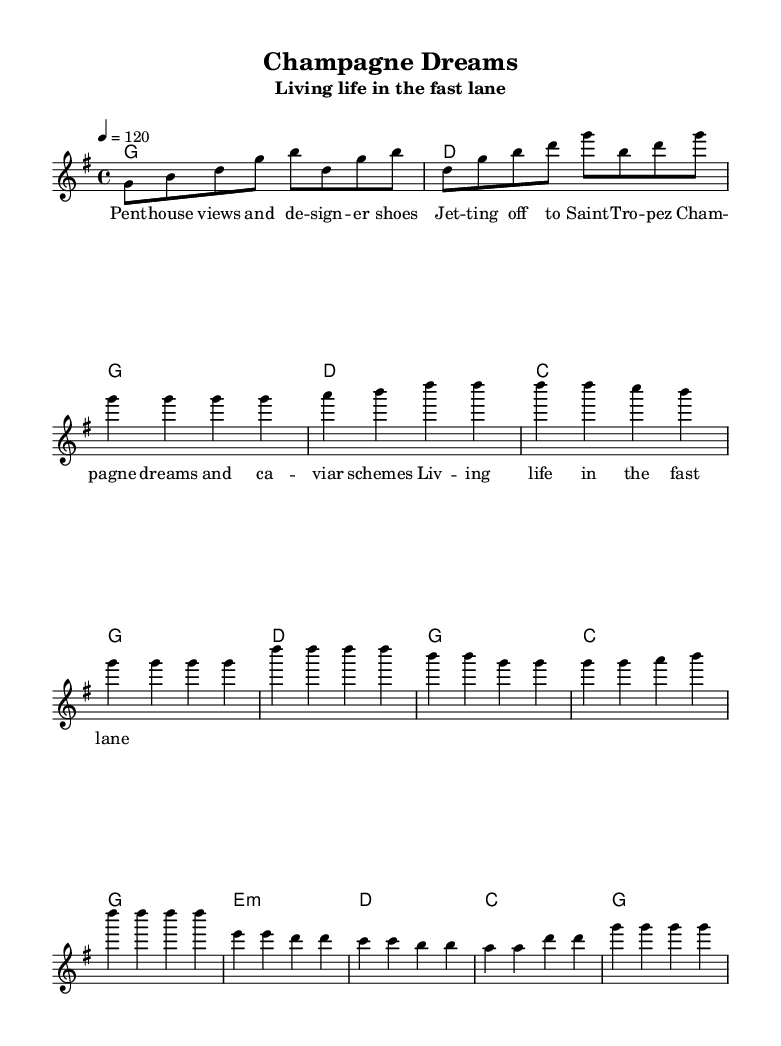What is the key signature of this music? The key signature is G major, which has one sharp (F#).
Answer: G major What is the time signature of the piece? The time signature is 4/4, which indicates four beats per measure.
Answer: 4/4 What is the tempo marking for the piece? The tempo marking is 120 beats per minute, indicated by the note '4 = 120'.
Answer: 120 How many measures are in the verse? The verse consists of four measures based on the melody line.
Answer: 4 What is the first note of the chorus? The first note of the chorus is D, which is found in the melody section of the sheet music.
Answer: D What is the overall theme of the lyrics? The overall theme of the lyrics revolves around luxury and living life to the fullest, as indicated by phrases like "Champagne dreams."
Answer: Luxury What harmony accompanies the first verse? The harmonies for the first verse are G major, D major, C major, and G major, as shown in the chord line.
Answer: G, D, C, G 